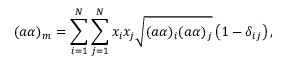Convert formula to latex. <formula><loc_0><loc_0><loc_500><loc_500>( a \alpha ) _ { m } = \sum _ { i = 1 } ^ { N } \sum _ { j = 1 } ^ { N } x _ { i } x _ { j } \sqrt { ( a \alpha ) _ { i } ( a \alpha ) _ { j } } \left ( 1 - \delta _ { i j } \right ) ,</formula> 